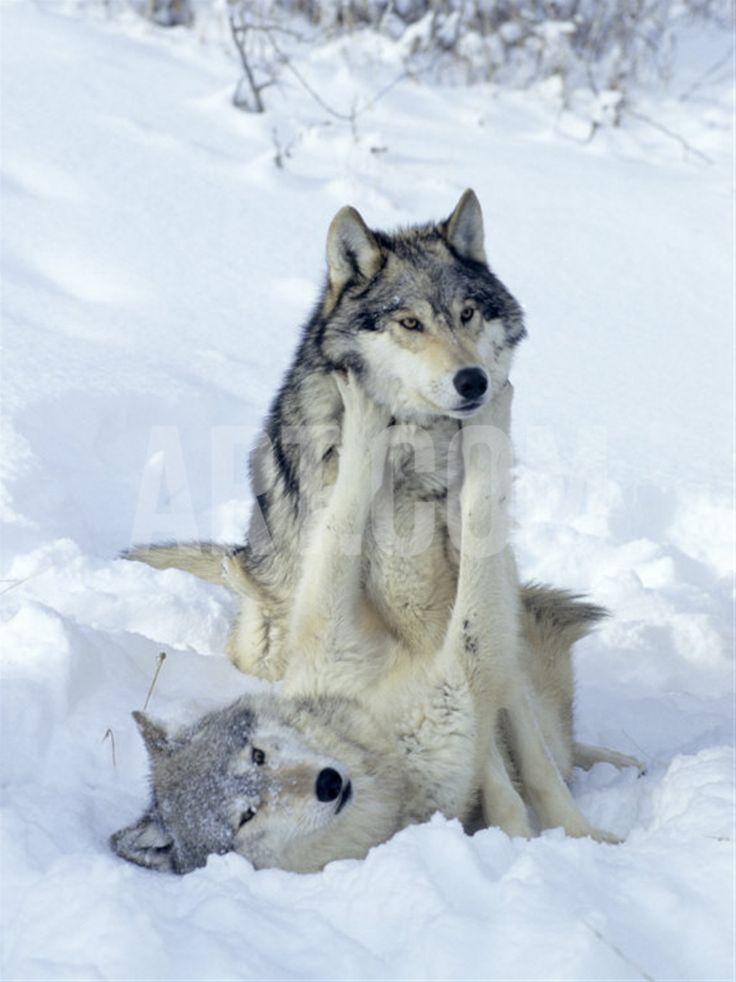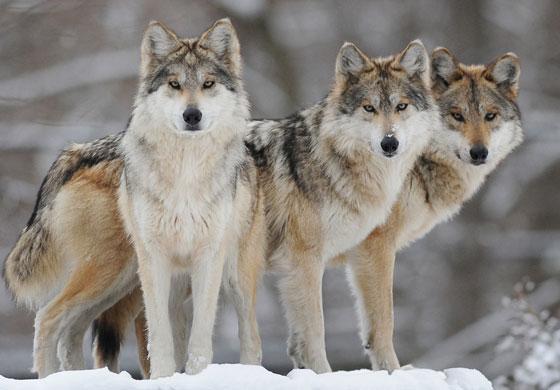The first image is the image on the left, the second image is the image on the right. Examine the images to the left and right. Is the description "There are no more than two wolves standing outside." accurate? Answer yes or no. No. 